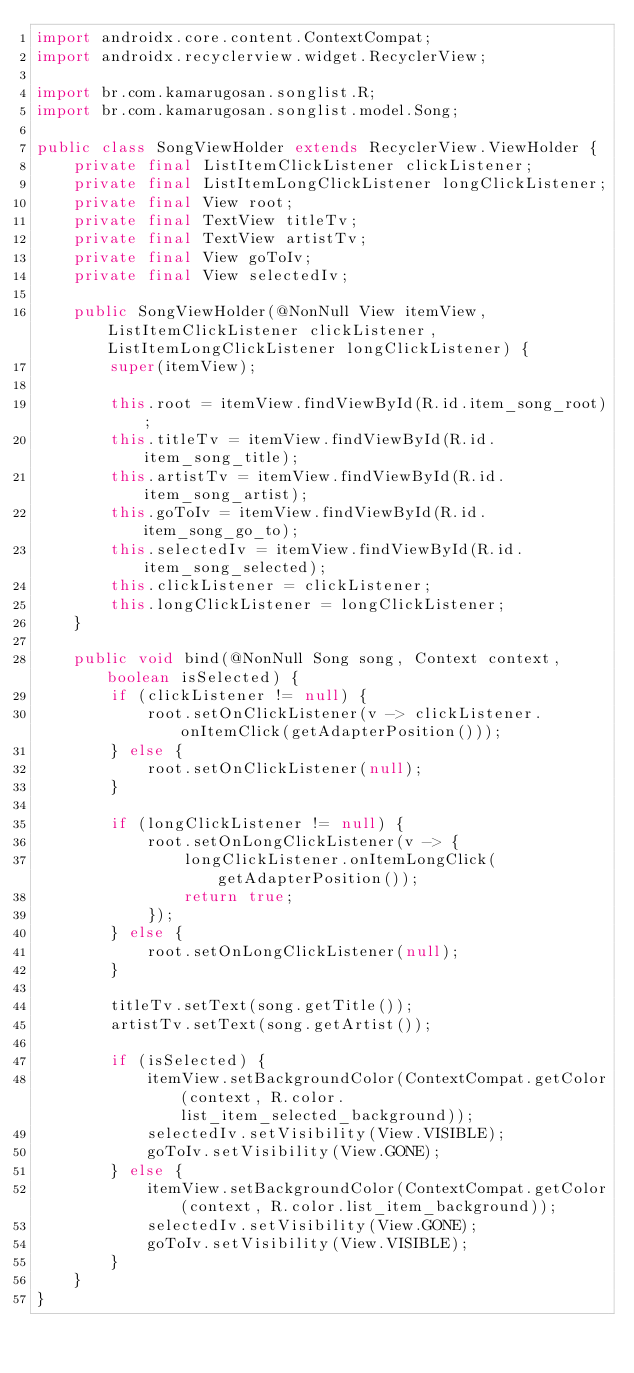Convert code to text. <code><loc_0><loc_0><loc_500><loc_500><_Java_>import androidx.core.content.ContextCompat;
import androidx.recyclerview.widget.RecyclerView;

import br.com.kamarugosan.songlist.R;
import br.com.kamarugosan.songlist.model.Song;

public class SongViewHolder extends RecyclerView.ViewHolder {
    private final ListItemClickListener clickListener;
    private final ListItemLongClickListener longClickListener;
    private final View root;
    private final TextView titleTv;
    private final TextView artistTv;
    private final View goToIv;
    private final View selectedIv;

    public SongViewHolder(@NonNull View itemView, ListItemClickListener clickListener, ListItemLongClickListener longClickListener) {
        super(itemView);

        this.root = itemView.findViewById(R.id.item_song_root);
        this.titleTv = itemView.findViewById(R.id.item_song_title);
        this.artistTv = itemView.findViewById(R.id.item_song_artist);
        this.goToIv = itemView.findViewById(R.id.item_song_go_to);
        this.selectedIv = itemView.findViewById(R.id.item_song_selected);
        this.clickListener = clickListener;
        this.longClickListener = longClickListener;
    }

    public void bind(@NonNull Song song, Context context, boolean isSelected) {
        if (clickListener != null) {
            root.setOnClickListener(v -> clickListener.onItemClick(getAdapterPosition()));
        } else {
            root.setOnClickListener(null);
        }

        if (longClickListener != null) {
            root.setOnLongClickListener(v -> {
                longClickListener.onItemLongClick(getAdapterPosition());
                return true;
            });
        } else {
            root.setOnLongClickListener(null);
        }

        titleTv.setText(song.getTitle());
        artistTv.setText(song.getArtist());

        if (isSelected) {
            itemView.setBackgroundColor(ContextCompat.getColor(context, R.color.list_item_selected_background));
            selectedIv.setVisibility(View.VISIBLE);
            goToIv.setVisibility(View.GONE);
        } else {
            itemView.setBackgroundColor(ContextCompat.getColor(context, R.color.list_item_background));
            selectedIv.setVisibility(View.GONE);
            goToIv.setVisibility(View.VISIBLE);
        }
    }
}
</code> 